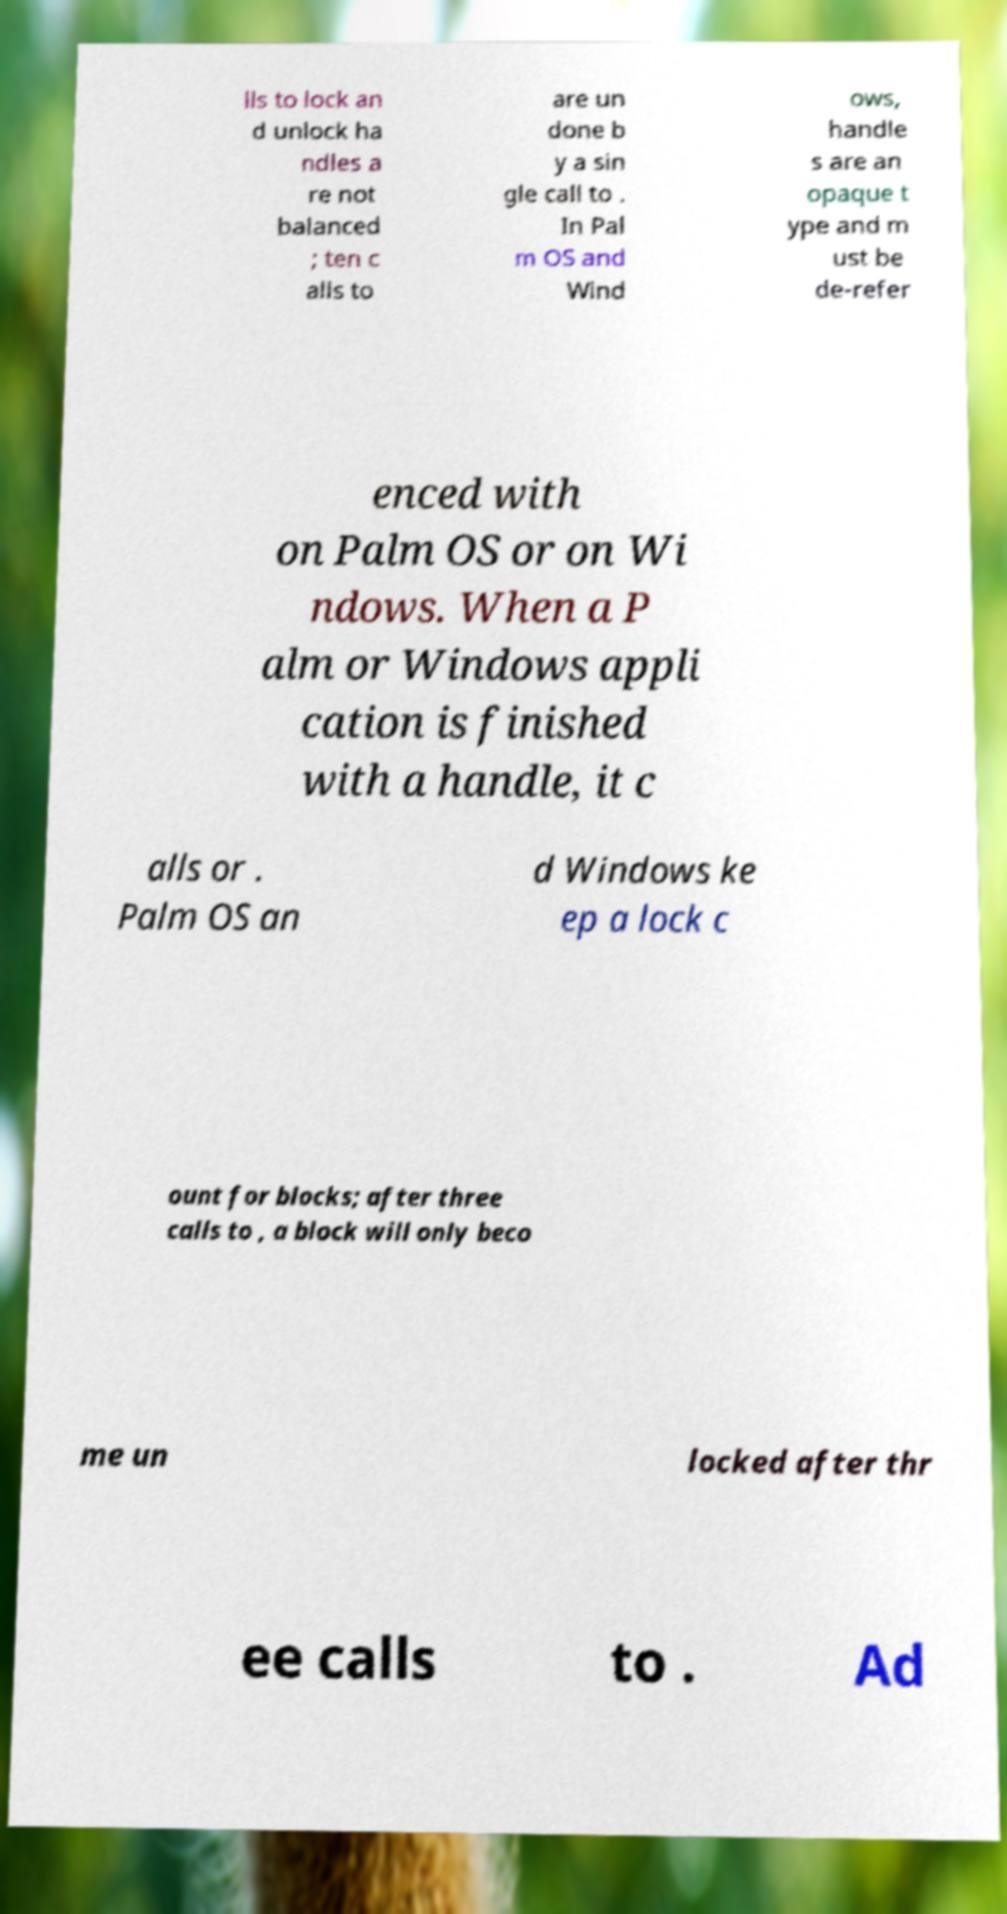Can you read and provide the text displayed in the image?This photo seems to have some interesting text. Can you extract and type it out for me? lls to lock an d unlock ha ndles a re not balanced ; ten c alls to are un done b y a sin gle call to . In Pal m OS and Wind ows, handle s are an opaque t ype and m ust be de-refer enced with on Palm OS or on Wi ndows. When a P alm or Windows appli cation is finished with a handle, it c alls or . Palm OS an d Windows ke ep a lock c ount for blocks; after three calls to , a block will only beco me un locked after thr ee calls to . Ad 